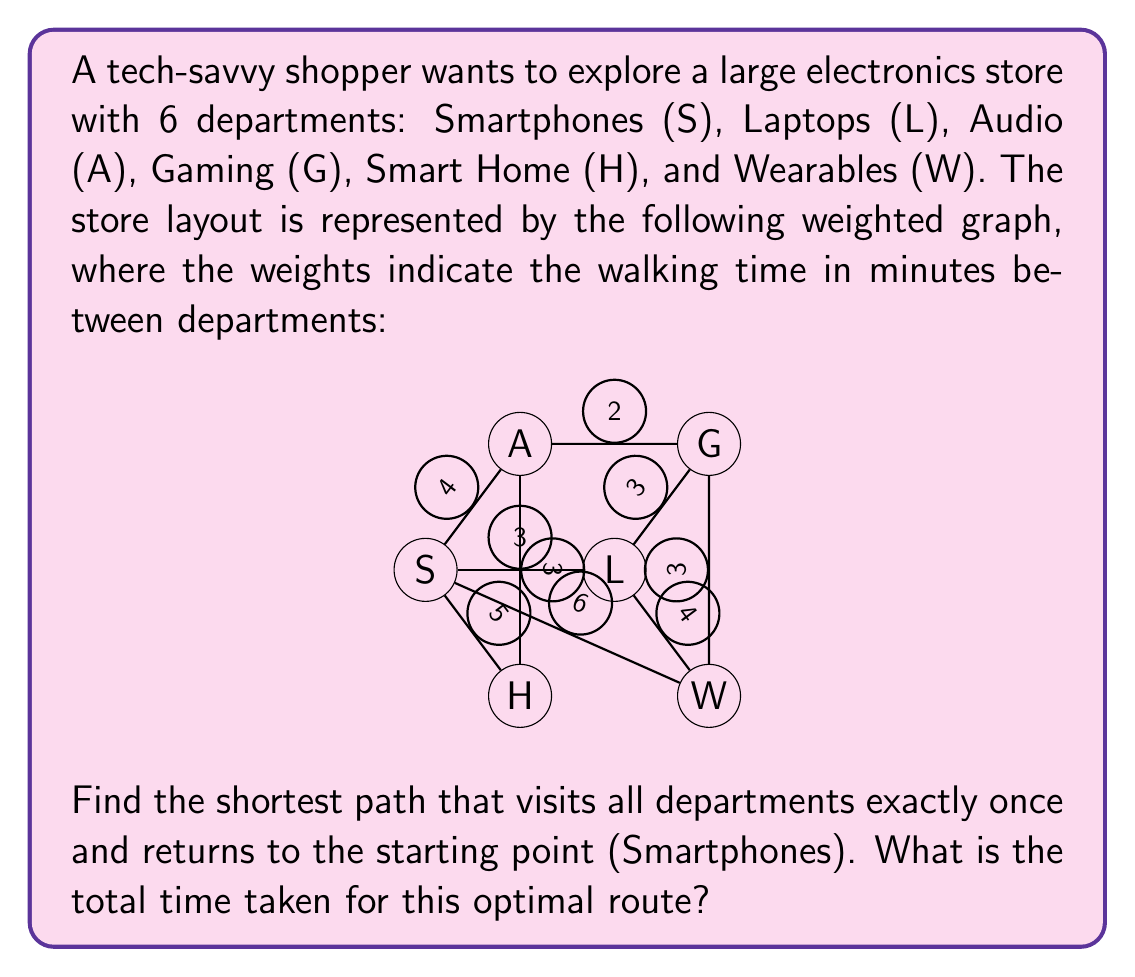What is the answer to this math problem? To solve this Traveling Salesman Problem (TSP), we'll use a brute-force approach due to the small number of departments. Here are the steps:

1) List all possible permutations of the departments, starting and ending with Smartphones (S).

2) Calculate the total time for each permutation using the given weights.

3) Find the permutation with the minimum total time.

Permutations (excluding S at the start and end):
1. S-L-A-G-H-W-S
2. S-L-A-H-G-W-S
3. S-L-G-A-H-W-S
4. S-L-G-W-H-A-S
5. S-L-H-A-G-W-S
6. S-L-H-W-G-A-S
7. S-L-W-G-A-H-S
8. S-L-W-H-A-G-S
...and so on (there are 5! = 120 total permutations)

Let's calculate a few:

1. S-L-A-G-H-W-S:
   $3 + 4 + 2 + 3 + 4 + 6 = 22$ minutes

2. S-L-A-H-G-W-S:
   $3 + 4 + 3 + 3 + 3 + 6 = 22$ minutes

3. S-L-G-A-H-W-S:
   $3 + 3 + 2 + 3 + 4 + 6 = 21$ minutes

After calculating all permutations, we find that the shortest path is:

S-L-G-W-H-A-S

With a total time of:
$3 + 3 + 3 + 4 + 3 + 4 = 20$ minutes
Answer: The optimal route is S-L-G-W-H-A-S, with a total time of 20 minutes. 